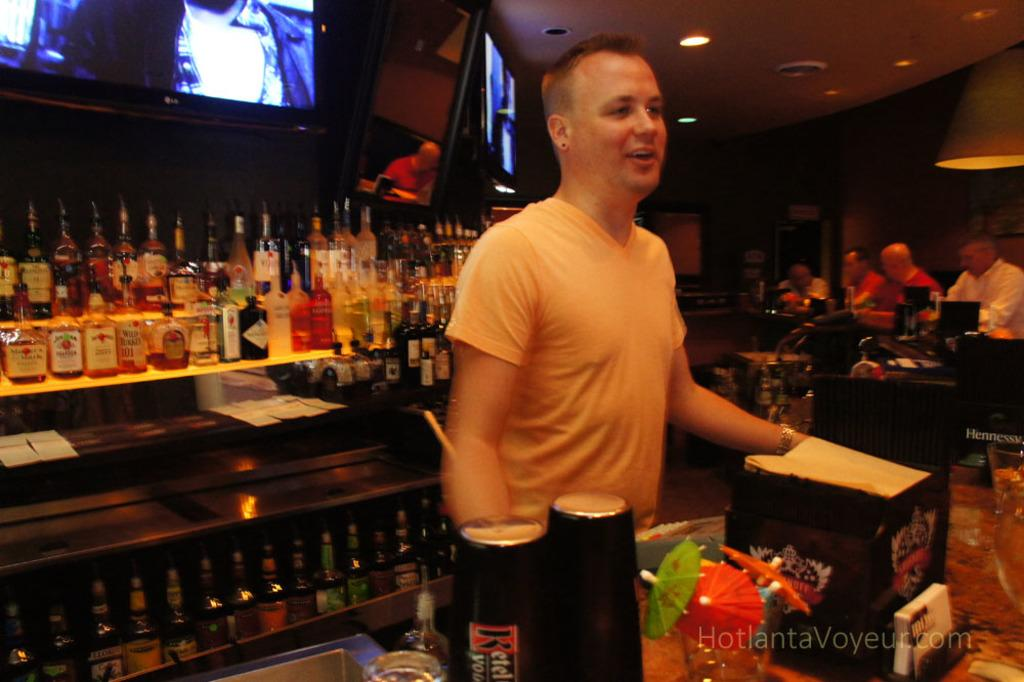<image>
Relay a brief, clear account of the picture shown. A man at a bar where there are lots of alcoholic beverages including Hennessy 